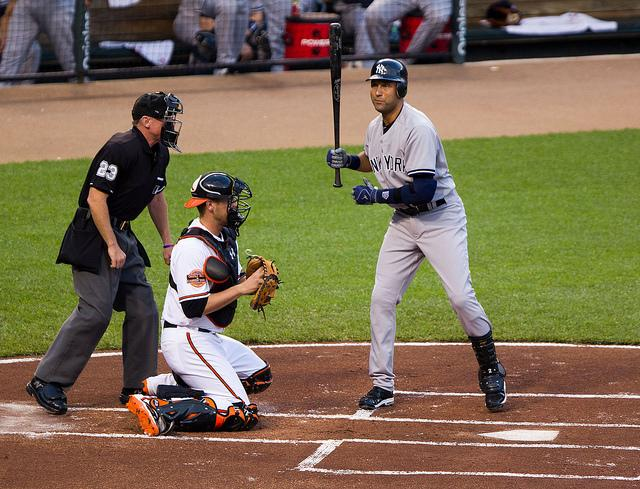Who is the man up to bat?

Choices:
A) reggie jackson
B) derek jeter
C) alexa rodriguez
D) mariano rivera derek jeter 